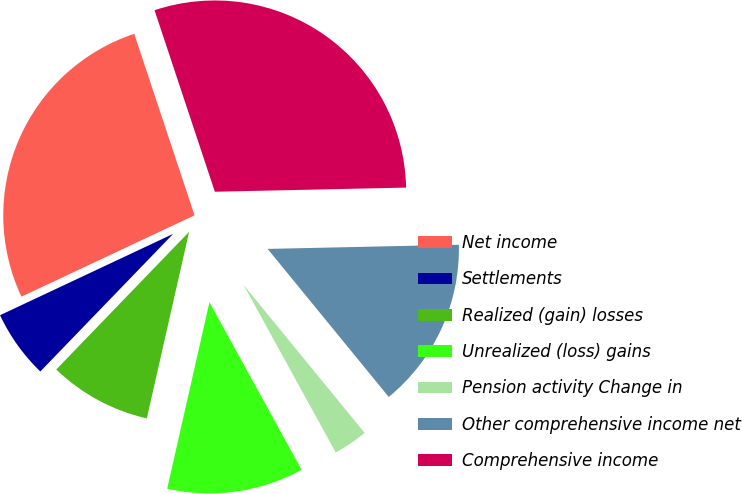<chart> <loc_0><loc_0><loc_500><loc_500><pie_chart><fcel>Net income<fcel>Settlements<fcel>Realized (gain) losses<fcel>Unrealized (loss) gains<fcel>Pension activity Change in<fcel>Other comprehensive income net<fcel>Comprehensive income<nl><fcel>26.88%<fcel>5.79%<fcel>8.67%<fcel>11.55%<fcel>2.91%<fcel>14.43%<fcel>29.76%<nl></chart> 